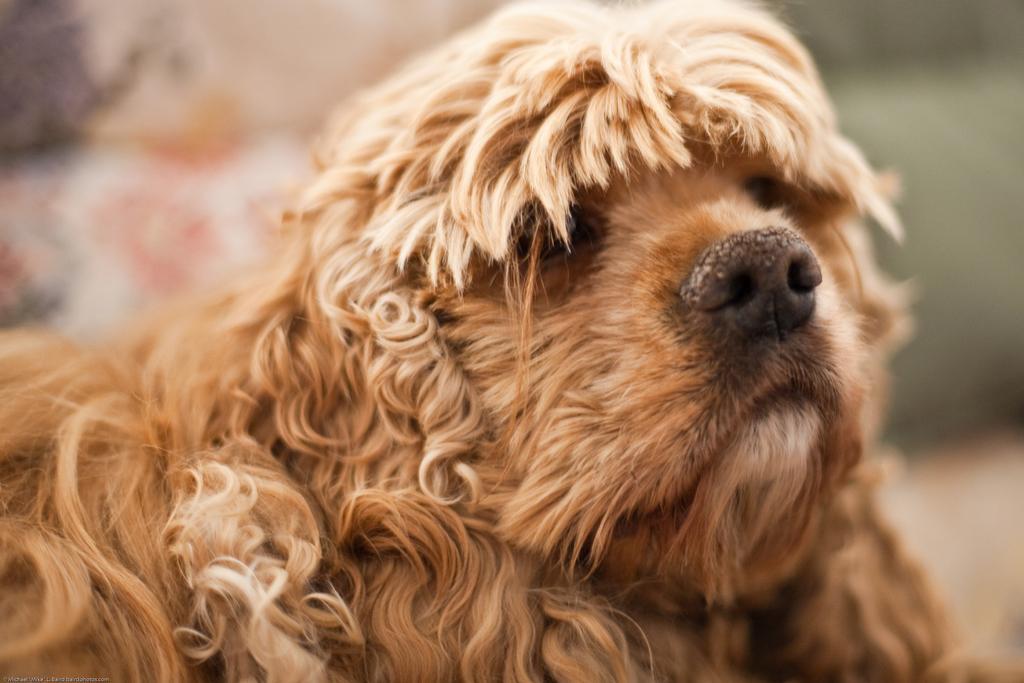Describe this image in one or two sentences. In this image I can see a dog in brown color and I can see blurred background. 